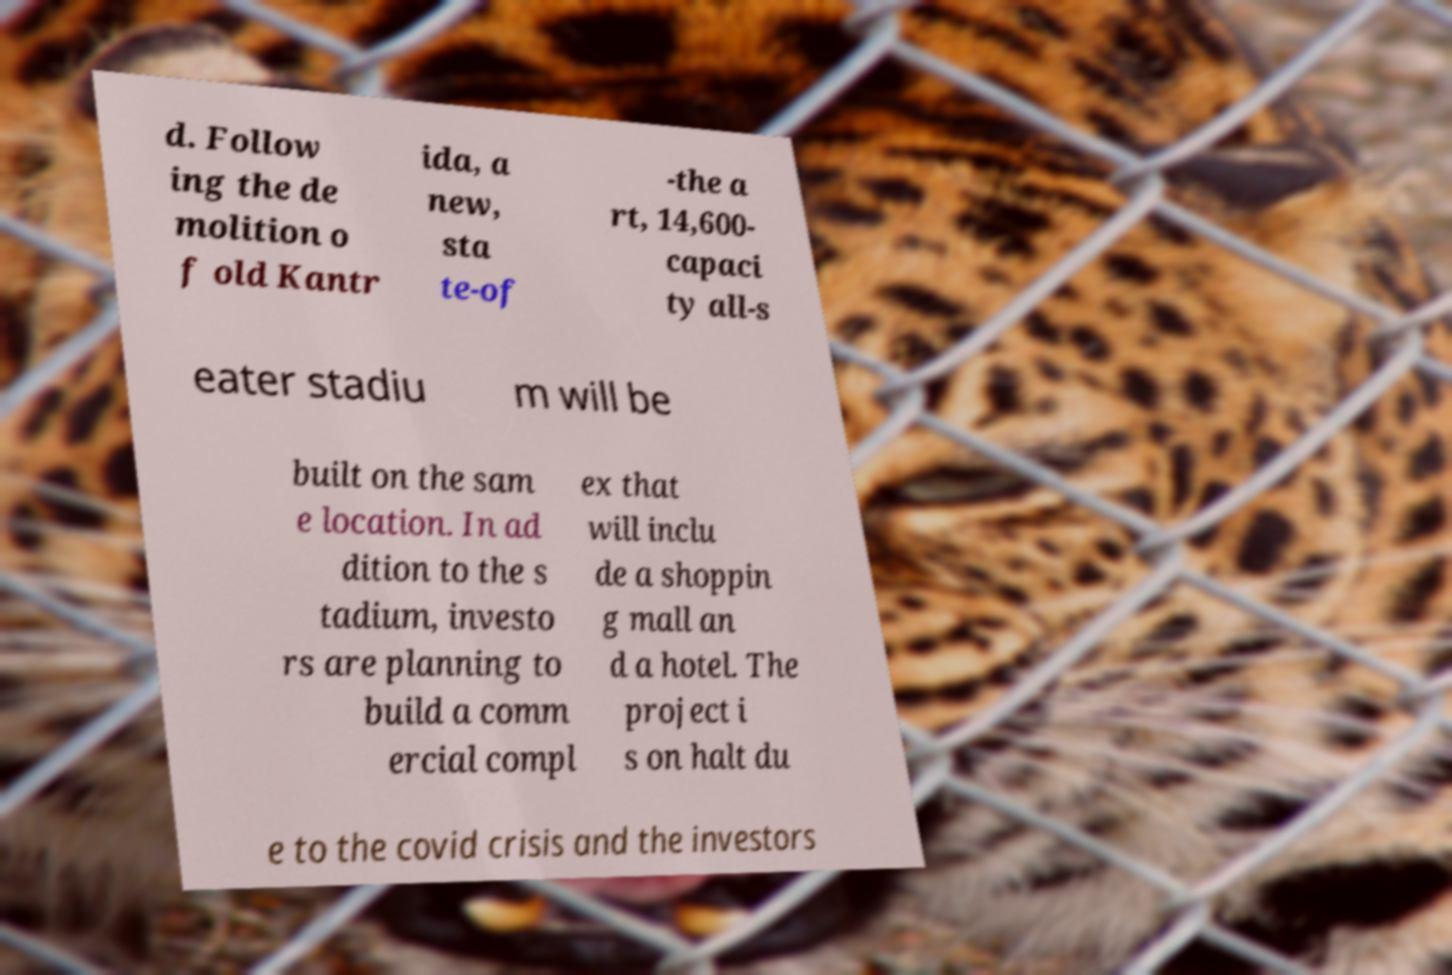Could you assist in decoding the text presented in this image and type it out clearly? d. Follow ing the de molition o f old Kantr ida, a new, sta te-of -the a rt, 14,600- capaci ty all-s eater stadiu m will be built on the sam e location. In ad dition to the s tadium, investo rs are planning to build a comm ercial compl ex that will inclu de a shoppin g mall an d a hotel. The project i s on halt du e to the covid crisis and the investors 